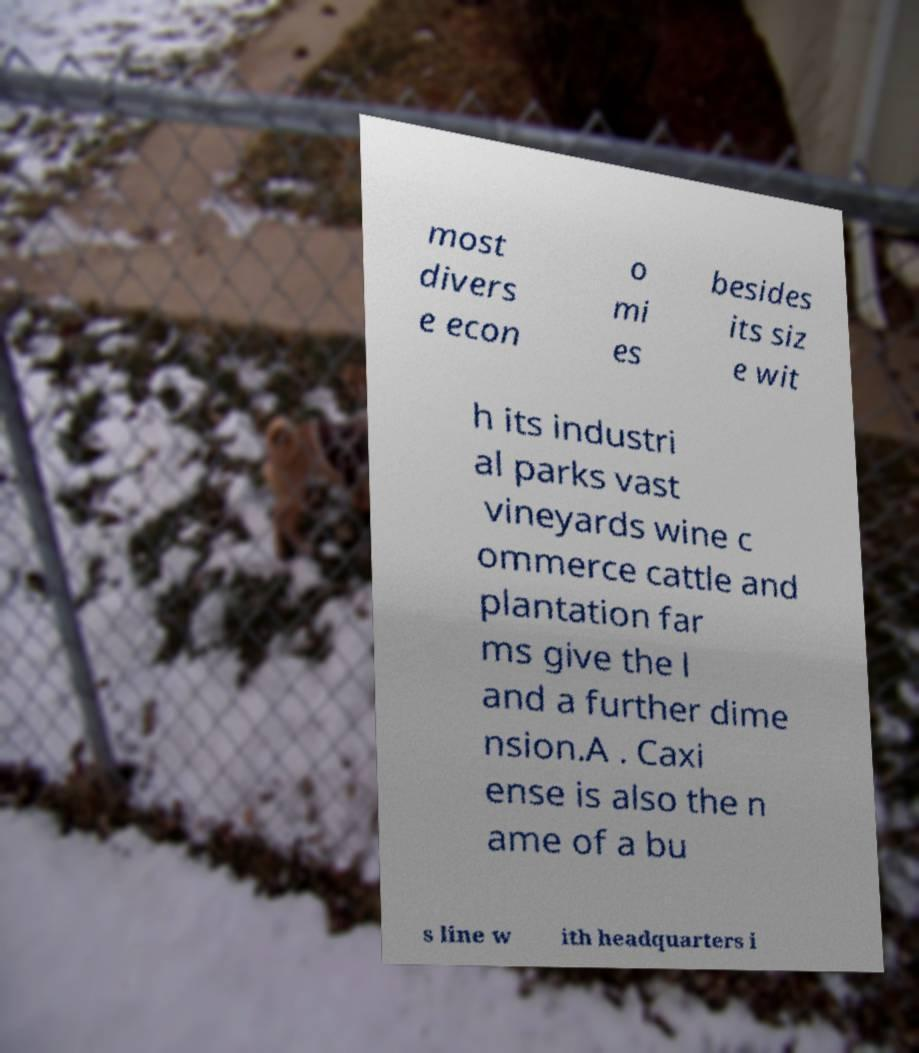Please identify and transcribe the text found in this image. most divers e econ o mi es besides its siz e wit h its industri al parks vast vineyards wine c ommerce cattle and plantation far ms give the l and a further dime nsion.A . Caxi ense is also the n ame of a bu s line w ith headquarters i 